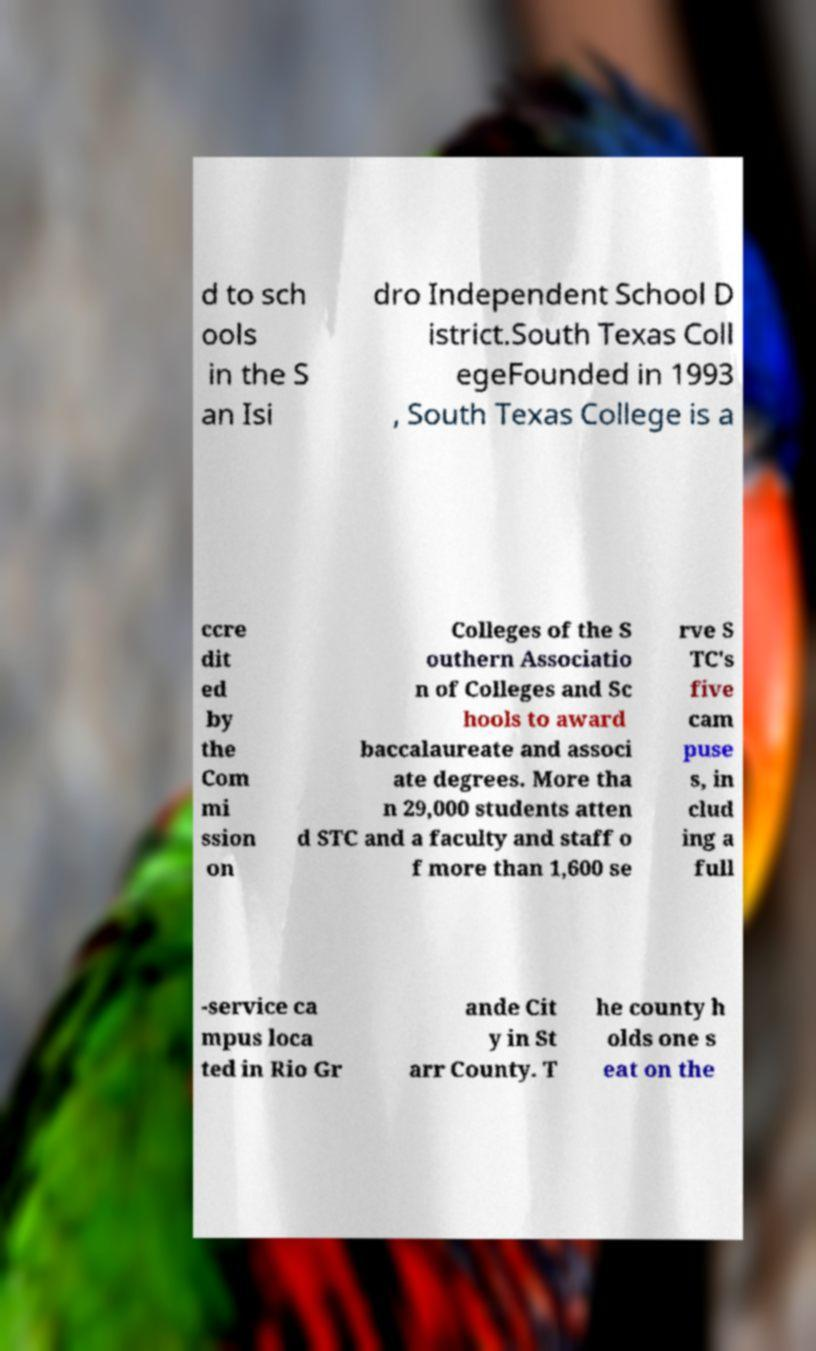There's text embedded in this image that I need extracted. Can you transcribe it verbatim? d to sch ools in the S an Isi dro Independent School D istrict.South Texas Coll egeFounded in 1993 , South Texas College is a ccre dit ed by the Com mi ssion on Colleges of the S outhern Associatio n of Colleges and Sc hools to award baccalaureate and associ ate degrees. More tha n 29,000 students atten d STC and a faculty and staff o f more than 1,600 se rve S TC's five cam puse s, in clud ing a full -service ca mpus loca ted in Rio Gr ande Cit y in St arr County. T he county h olds one s eat on the 